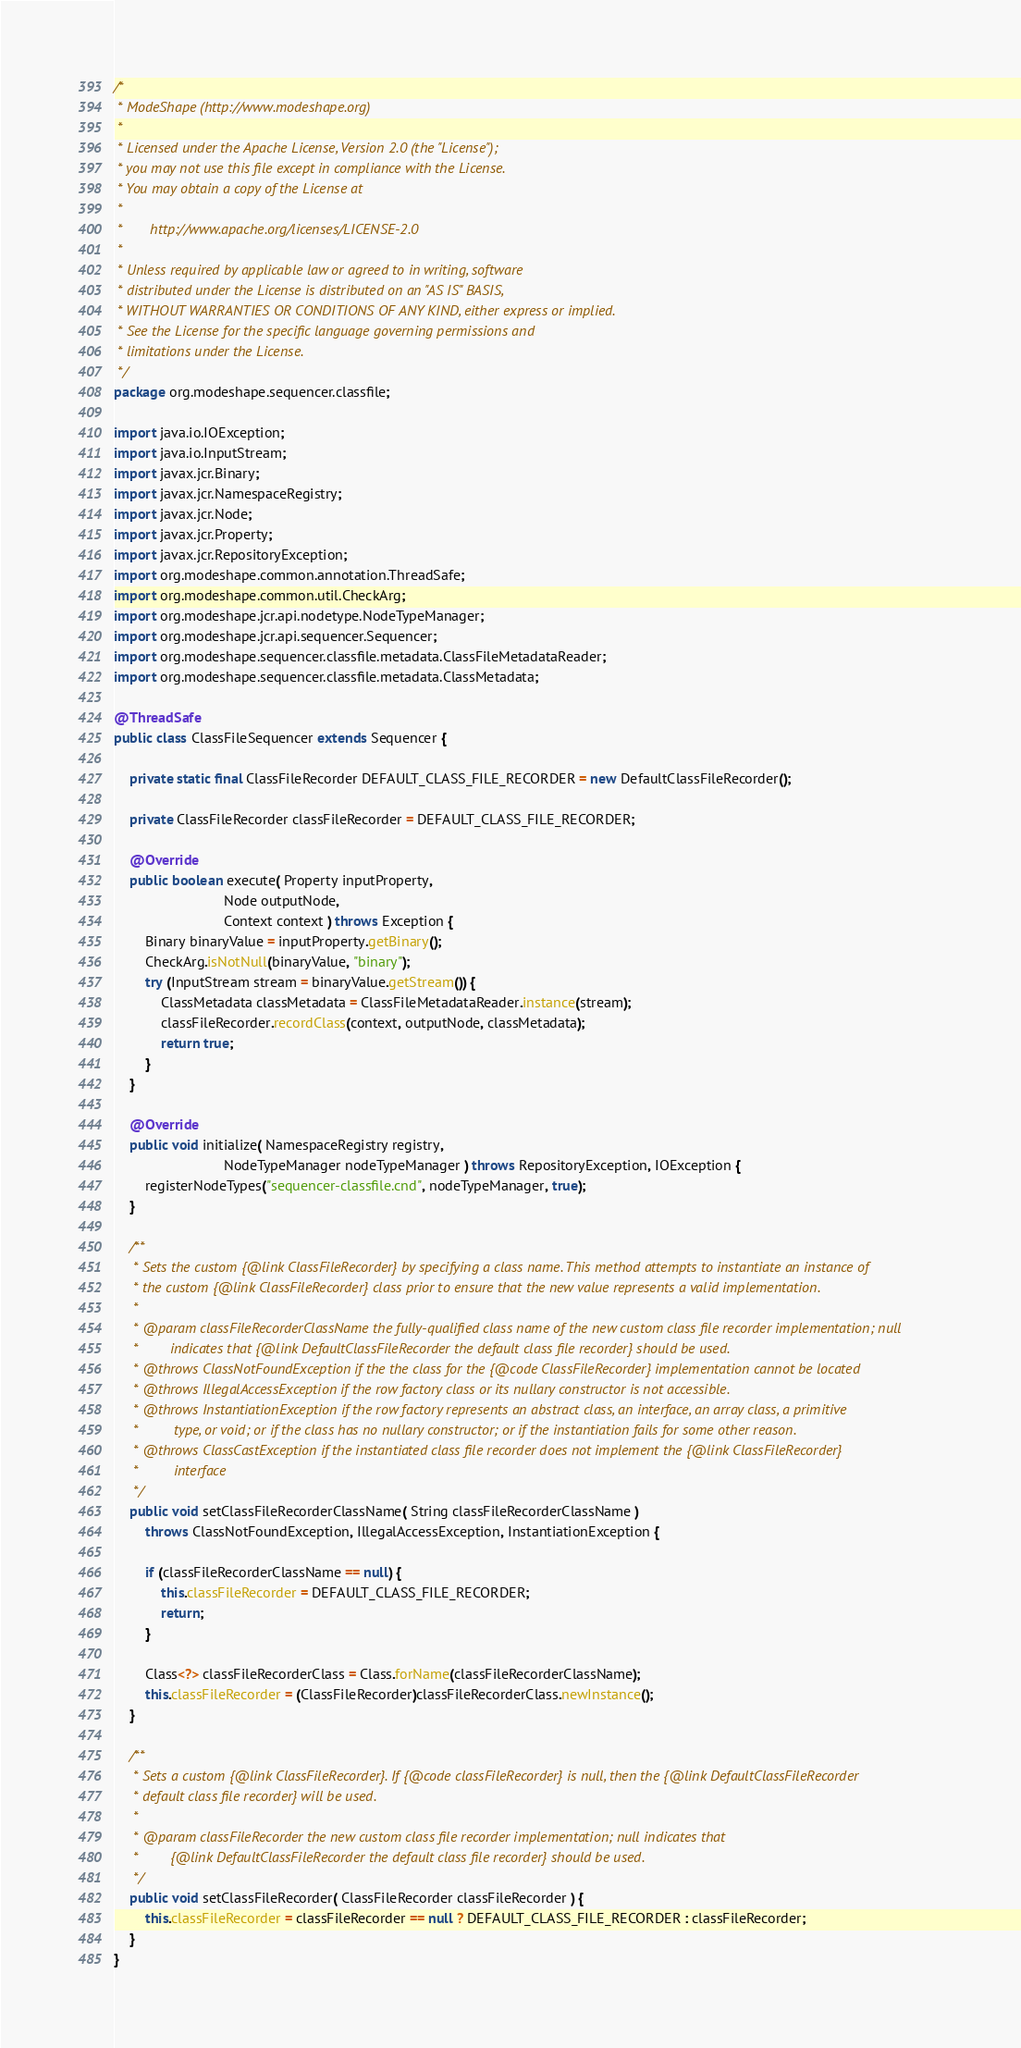Convert code to text. <code><loc_0><loc_0><loc_500><loc_500><_Java_>/*
 * ModeShape (http://www.modeshape.org)
 *
 * Licensed under the Apache License, Version 2.0 (the "License");
 * you may not use this file except in compliance with the License.
 * You may obtain a copy of the License at
 *
 *       http://www.apache.org/licenses/LICENSE-2.0
 *
 * Unless required by applicable law or agreed to in writing, software
 * distributed under the License is distributed on an "AS IS" BASIS,
 * WITHOUT WARRANTIES OR CONDITIONS OF ANY KIND, either express or implied.
 * See the License for the specific language governing permissions and
 * limitations under the License.
 */
package org.modeshape.sequencer.classfile;

import java.io.IOException;
import java.io.InputStream;
import javax.jcr.Binary;
import javax.jcr.NamespaceRegistry;
import javax.jcr.Node;
import javax.jcr.Property;
import javax.jcr.RepositoryException;
import org.modeshape.common.annotation.ThreadSafe;
import org.modeshape.common.util.CheckArg;
import org.modeshape.jcr.api.nodetype.NodeTypeManager;
import org.modeshape.jcr.api.sequencer.Sequencer;
import org.modeshape.sequencer.classfile.metadata.ClassFileMetadataReader;
import org.modeshape.sequencer.classfile.metadata.ClassMetadata;

@ThreadSafe
public class ClassFileSequencer extends Sequencer {

    private static final ClassFileRecorder DEFAULT_CLASS_FILE_RECORDER = new DefaultClassFileRecorder();

    private ClassFileRecorder classFileRecorder = DEFAULT_CLASS_FILE_RECORDER;

    @Override
    public boolean execute( Property inputProperty,
                            Node outputNode,
                            Context context ) throws Exception {
        Binary binaryValue = inputProperty.getBinary();
        CheckArg.isNotNull(binaryValue, "binary");
        try (InputStream stream = binaryValue.getStream()) {
            ClassMetadata classMetadata = ClassFileMetadataReader.instance(stream);
            classFileRecorder.recordClass(context, outputNode, classMetadata);
            return true;
        }
    }

    @Override
    public void initialize( NamespaceRegistry registry,
                            NodeTypeManager nodeTypeManager ) throws RepositoryException, IOException {
        registerNodeTypes("sequencer-classfile.cnd", nodeTypeManager, true);
    }

    /**
     * Sets the custom {@link ClassFileRecorder} by specifying a class name. This method attempts to instantiate an instance of
     * the custom {@link ClassFileRecorder} class prior to ensure that the new value represents a valid implementation.
     * 
     * @param classFileRecorderClassName the fully-qualified class name of the new custom class file recorder implementation; null
     *        indicates that {@link DefaultClassFileRecorder the default class file recorder} should be used.
     * @throws ClassNotFoundException if the the class for the {@code ClassFileRecorder} implementation cannot be located
     * @throws IllegalAccessException if the row factory class or its nullary constructor is not accessible.
     * @throws InstantiationException if the row factory represents an abstract class, an interface, an array class, a primitive
     *         type, or void; or if the class has no nullary constructor; or if the instantiation fails for some other reason.
     * @throws ClassCastException if the instantiated class file recorder does not implement the {@link ClassFileRecorder}
     *         interface
     */
    public void setClassFileRecorderClassName( String classFileRecorderClassName )
        throws ClassNotFoundException, IllegalAccessException, InstantiationException {

        if (classFileRecorderClassName == null) {
            this.classFileRecorder = DEFAULT_CLASS_FILE_RECORDER;
            return;
        }

        Class<?> classFileRecorderClass = Class.forName(classFileRecorderClassName);
        this.classFileRecorder = (ClassFileRecorder)classFileRecorderClass.newInstance();
    }

    /**
     * Sets a custom {@link ClassFileRecorder}. If {@code classFileRecorder} is null, then the {@link DefaultClassFileRecorder
     * default class file recorder} will be used.
     * 
     * @param classFileRecorder the new custom class file recorder implementation; null indicates that
     *        {@link DefaultClassFileRecorder the default class file recorder} should be used.
     */
    public void setClassFileRecorder( ClassFileRecorder classFileRecorder ) {
        this.classFileRecorder = classFileRecorder == null ? DEFAULT_CLASS_FILE_RECORDER : classFileRecorder;
    }
}
</code> 